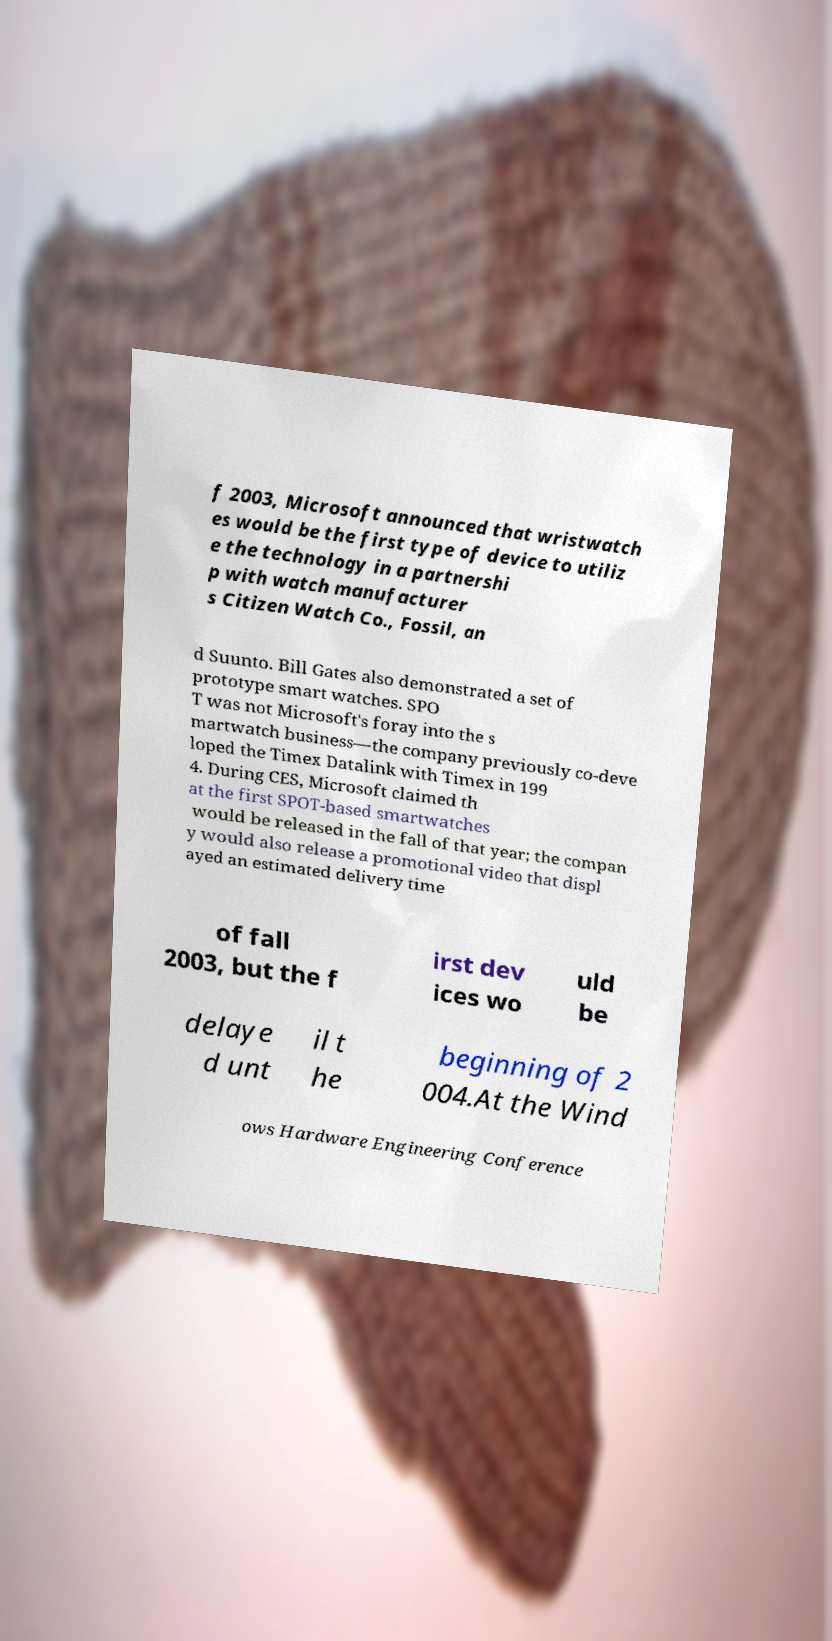Please read and relay the text visible in this image. What does it say? f 2003, Microsoft announced that wristwatch es would be the first type of device to utiliz e the technology in a partnershi p with watch manufacturer s Citizen Watch Co., Fossil, an d Suunto. Bill Gates also demonstrated a set of prototype smart watches. SPO T was not Microsoft's foray into the s martwatch business—the company previously co-deve loped the Timex Datalink with Timex in 199 4. During CES, Microsoft claimed th at the first SPOT-based smartwatches would be released in the fall of that year; the compan y would also release a promotional video that displ ayed an estimated delivery time of fall 2003, but the f irst dev ices wo uld be delaye d unt il t he beginning of 2 004.At the Wind ows Hardware Engineering Conference 